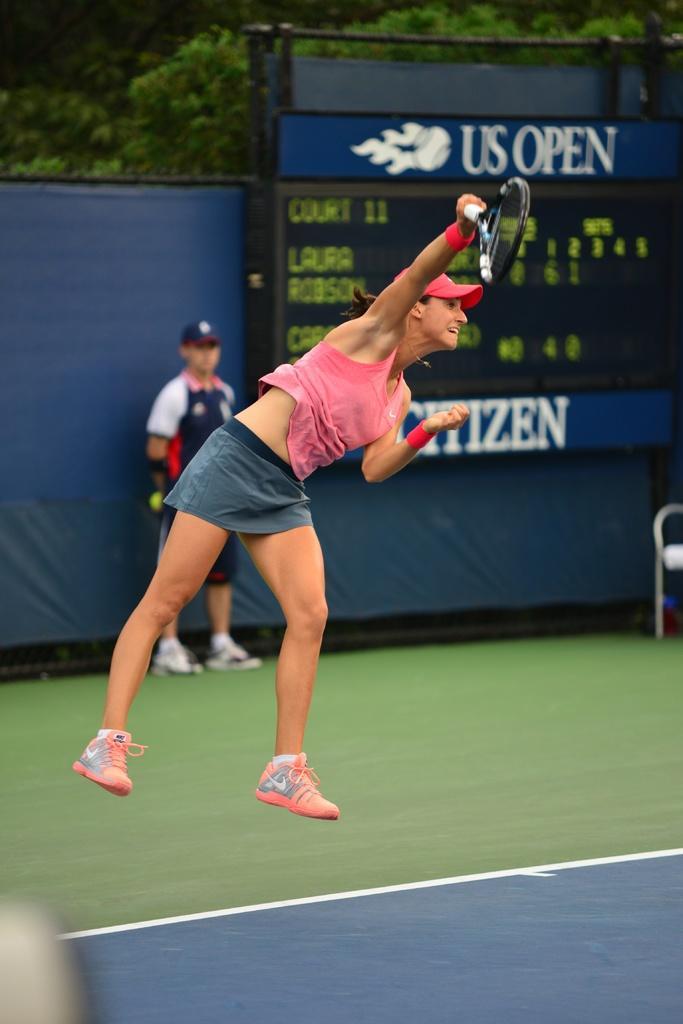In one or two sentences, can you explain what this image depicts? A lady with pink color top is jumping and biting with the racket. This is a court. Behind her there is a man standing. And there is a scoreboard. In the background there is a blue color cloth and some trees. 